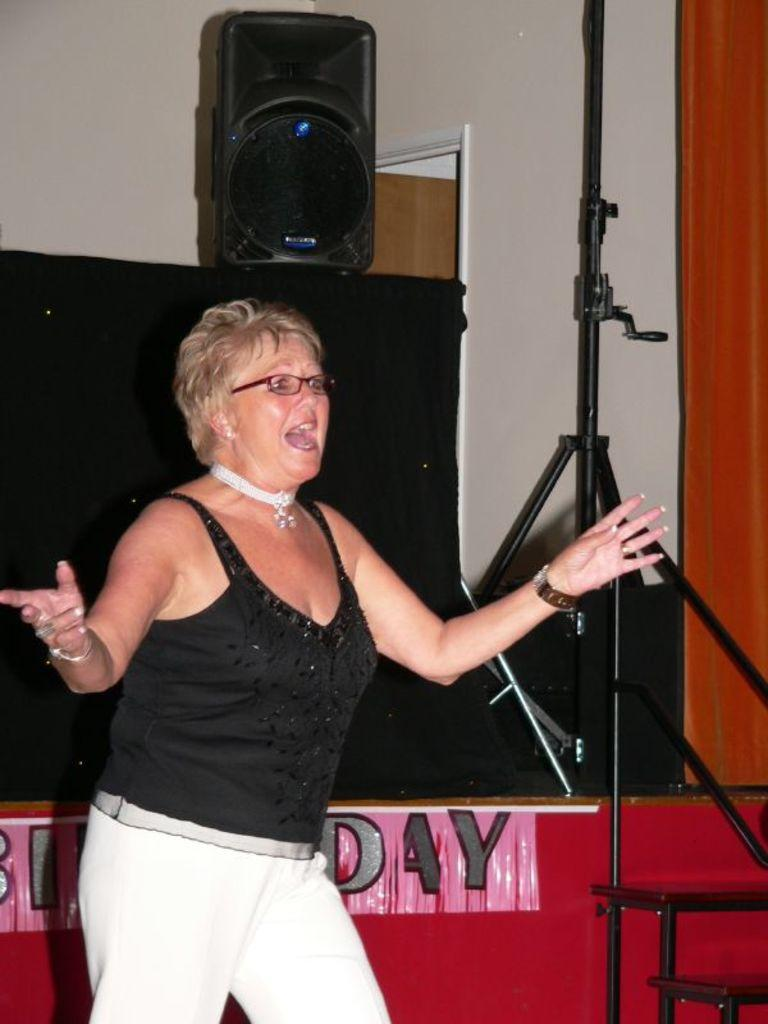Who is the main subject in the image? There is a woman in the image. What is the woman doing in the image? The woman is standing and singing. What object is present in the image that might be used for amplifying sound? There is a speaker in the image. What type of text can be seen in the image? There is text on a cloth in the image. What architectural feature is visible in the background of the image? There is a door visible in the background of the image. What type of ground can be seen beneath the woman in the image? There is no ground visible in the image; it appears to be an indoor setting with a door in the background. 